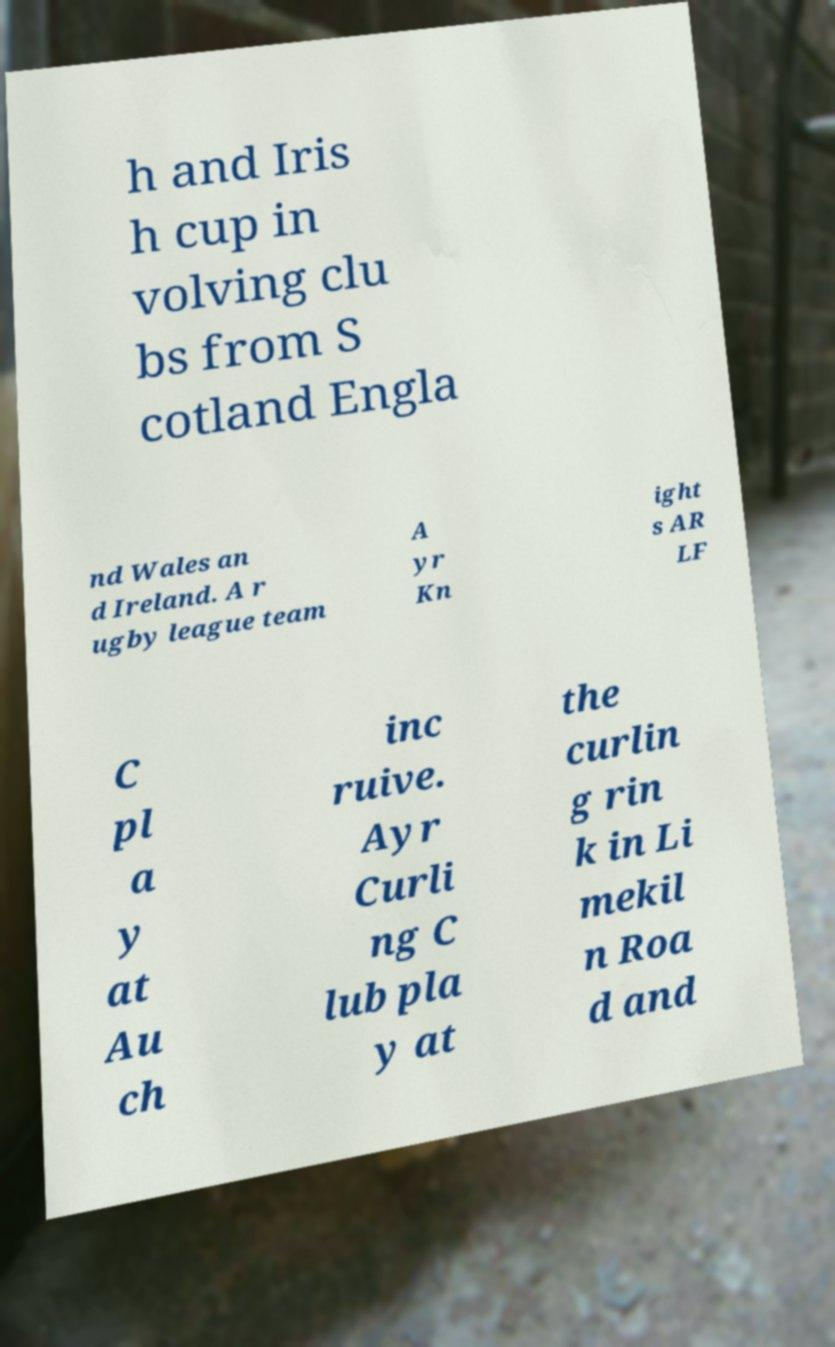Please identify and transcribe the text found in this image. h and Iris h cup in volving clu bs from S cotland Engla nd Wales an d Ireland. A r ugby league team A yr Kn ight s AR LF C pl a y at Au ch inc ruive. Ayr Curli ng C lub pla y at the curlin g rin k in Li mekil n Roa d and 